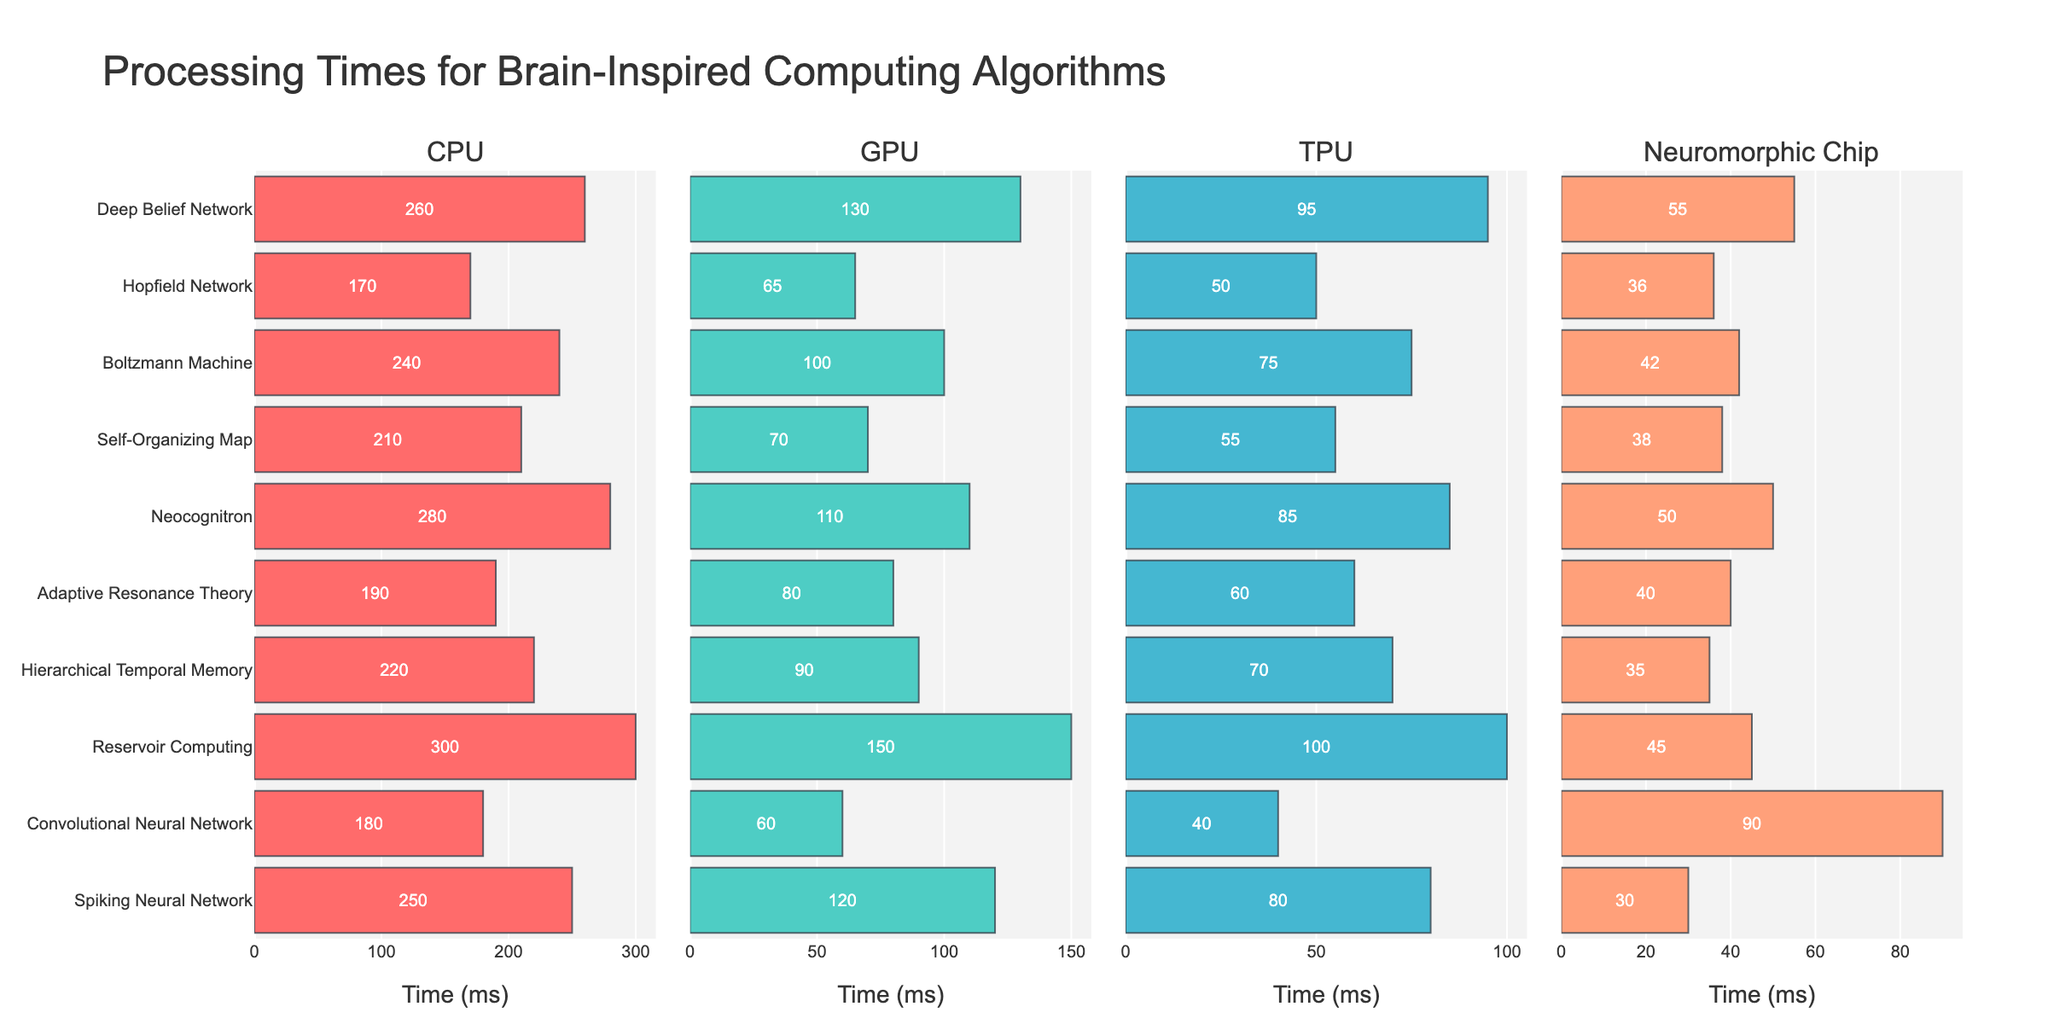What's the title of the figure? The title is usually placed at the top of the figure, and for horizontal subplots, it is typically displayed centrally. In this case, the title is clearly stated as "Processing Times for Brain-Inspired Computing Algorithms".
Answer: Processing Times for Brain-Inspired Computing Algorithms What are the four hardware platforms compared in the figure? The subplot titles specify the hardware platforms being compared. They are "CPU", "GPU", "TPU", and "Neuromorphic Chip".
Answer: CPU, GPU, TPU, Neuromorphic Chip Which algorithm has the shortest processing time on the Neuromorphic Chip? Observing the "Neuromorphic Chip" subplot, the shortest bar corresponds to the Spiking Neural Network with a processing time of 30 ms.
Answer: Spiking Neural Network What's the average processing time of the Boltzmann Machine across all hardware platforms? The processing times for the Boltzmann Machine are 240 ms (CPU), 100 ms (GPU), 75 ms (TPU), and 42 ms (Neuromorphic Chip). To find the average: (240 + 100 + 75 + 42) / 4 = 457 / 4 = 114.25 ms.
Answer: 114.25 ms Compare the processing times of the Hopfield Network and Reservoir Computing on a GPU. Which one is faster? On the GPU subplot, the Hopfield Network has a processing time of 65 ms while Reservoir Computing has a processing time of 150 ms. Thus, Hopfield Network is faster.
Answer: Hopfield Network Which algorithm shows the most significant reduction in processing time when moving from CPU to Neuromorphic Chip? By comparing the difference in processing times for each algorithm from CPU to Neuromorphic Chip, we can see that the Spiking Neural Network reduces from 250 ms (CPU) to 30 ms (Neuromorphic Chip), a reduction of 220 ms, which is the largest.
Answer: Spiking Neural Network What's the total processing time for the Hierarchical Temporal Memory algorithm across all hardware? The processing times for Hierarchical Temporal Memory are 220 ms (CPU), 90 ms (GPU), 70 ms (TPU), and 35 ms (Neuromorphic Chip). Summing these, 220 + 90 + 70 + 35 = 415 ms.
Answer: 415 ms Which hardware platform generally provides the fastest processing times for most algorithms? Observing all subplots, the Neuromorphic Chip generally has the shortest bars for most algorithms, indicating the fastest processing times.
Answer: Neuromorphic Chip What is the difference between the fastest and slowest processing times for the Neocognitron algorithm across all hardware platforms? The Neocognitron's processing times are 280 ms (CPU), 110 ms (GPU), 85 ms (TPU), and 50 ms (Neuromorphic Chip). The difference between the fastest (50 ms) and slowest (280 ms) times is 280 - 50 = 230 ms.
Answer: 230 ms Which algorithm has the second shortest processing time on the TPU? On the TPU subplot, after the Spiking Neural Network (80 ms), the Convolutional Neural Network has the second shortest processing time with 40 ms.
Answer: Convolutional Neural Network 